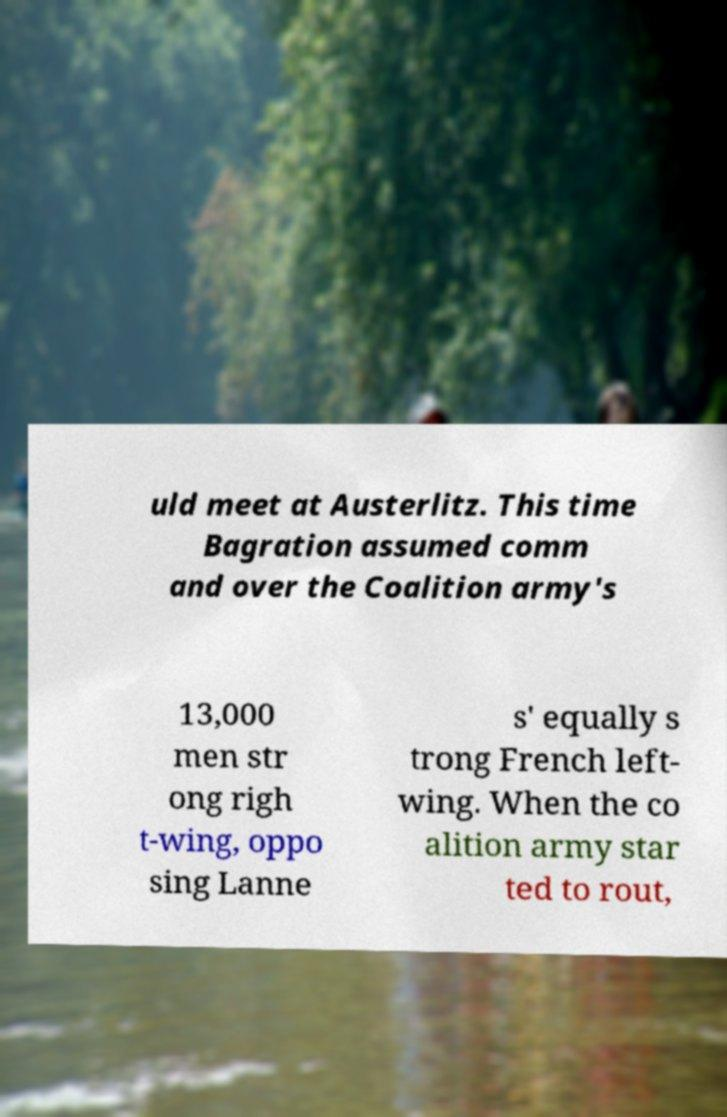There's text embedded in this image that I need extracted. Can you transcribe it verbatim? uld meet at Austerlitz. This time Bagration assumed comm and over the Coalition army's 13,000 men str ong righ t-wing, oppo sing Lanne s' equally s trong French left- wing. When the co alition army star ted to rout, 